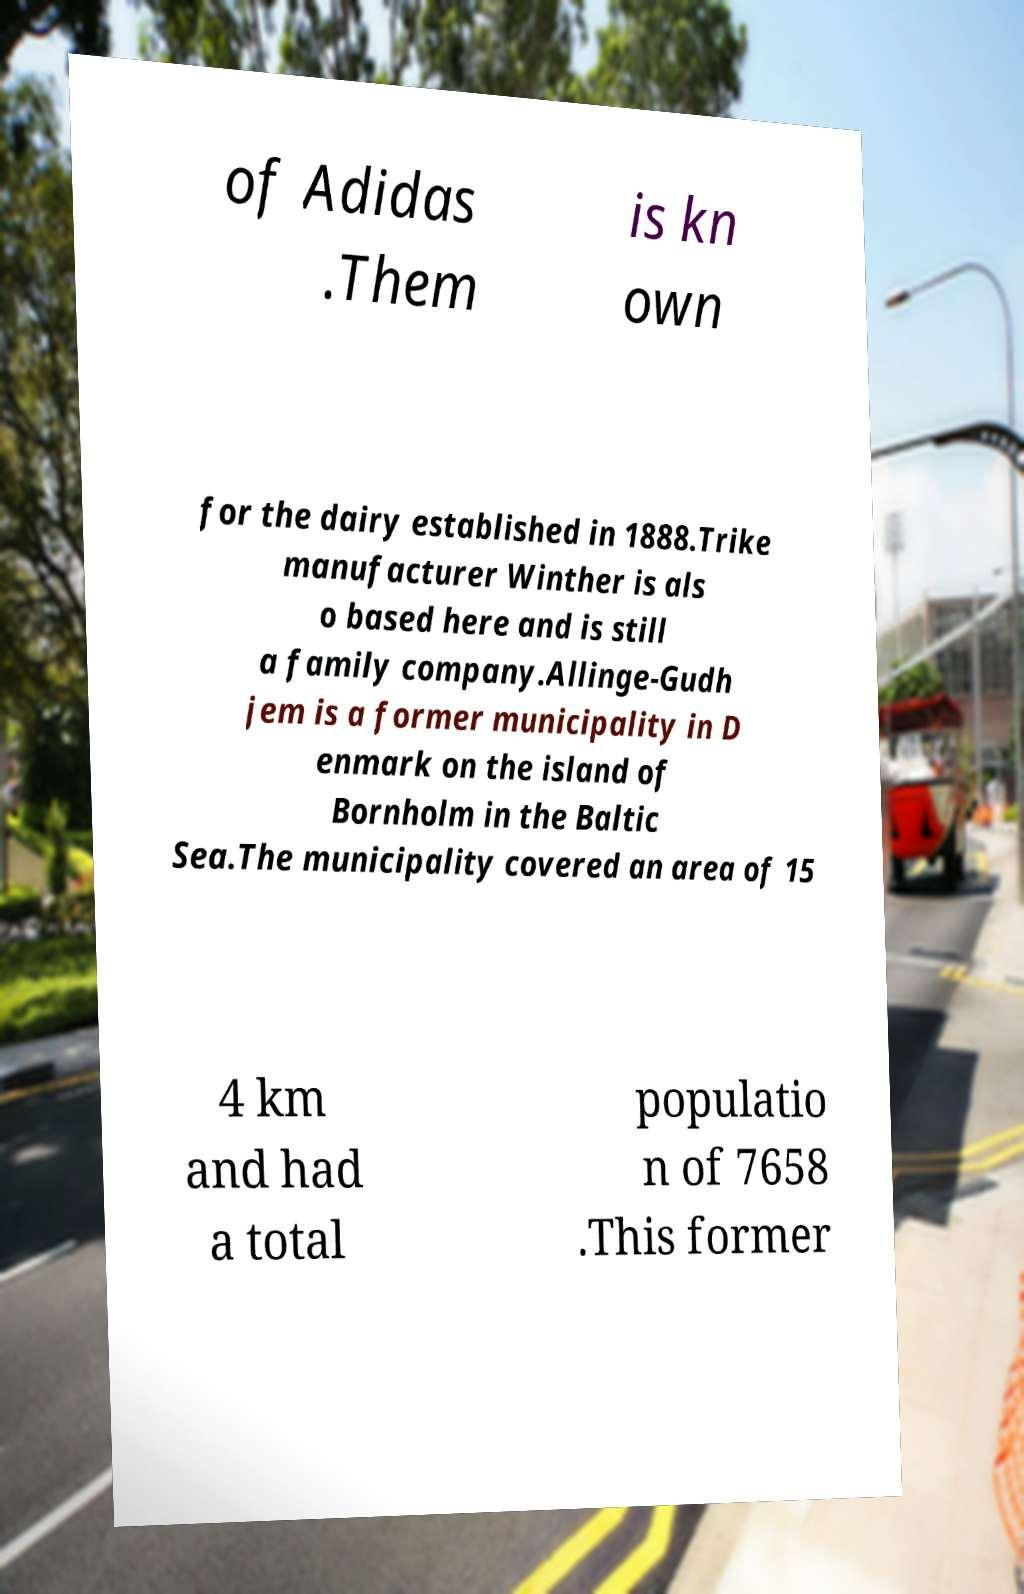Could you extract and type out the text from this image? of Adidas .Them is kn own for the dairy established in 1888.Trike manufacturer Winther is als o based here and is still a family company.Allinge-Gudh jem is a former municipality in D enmark on the island of Bornholm in the Baltic Sea.The municipality covered an area of 15 4 km and had a total populatio n of 7658 .This former 